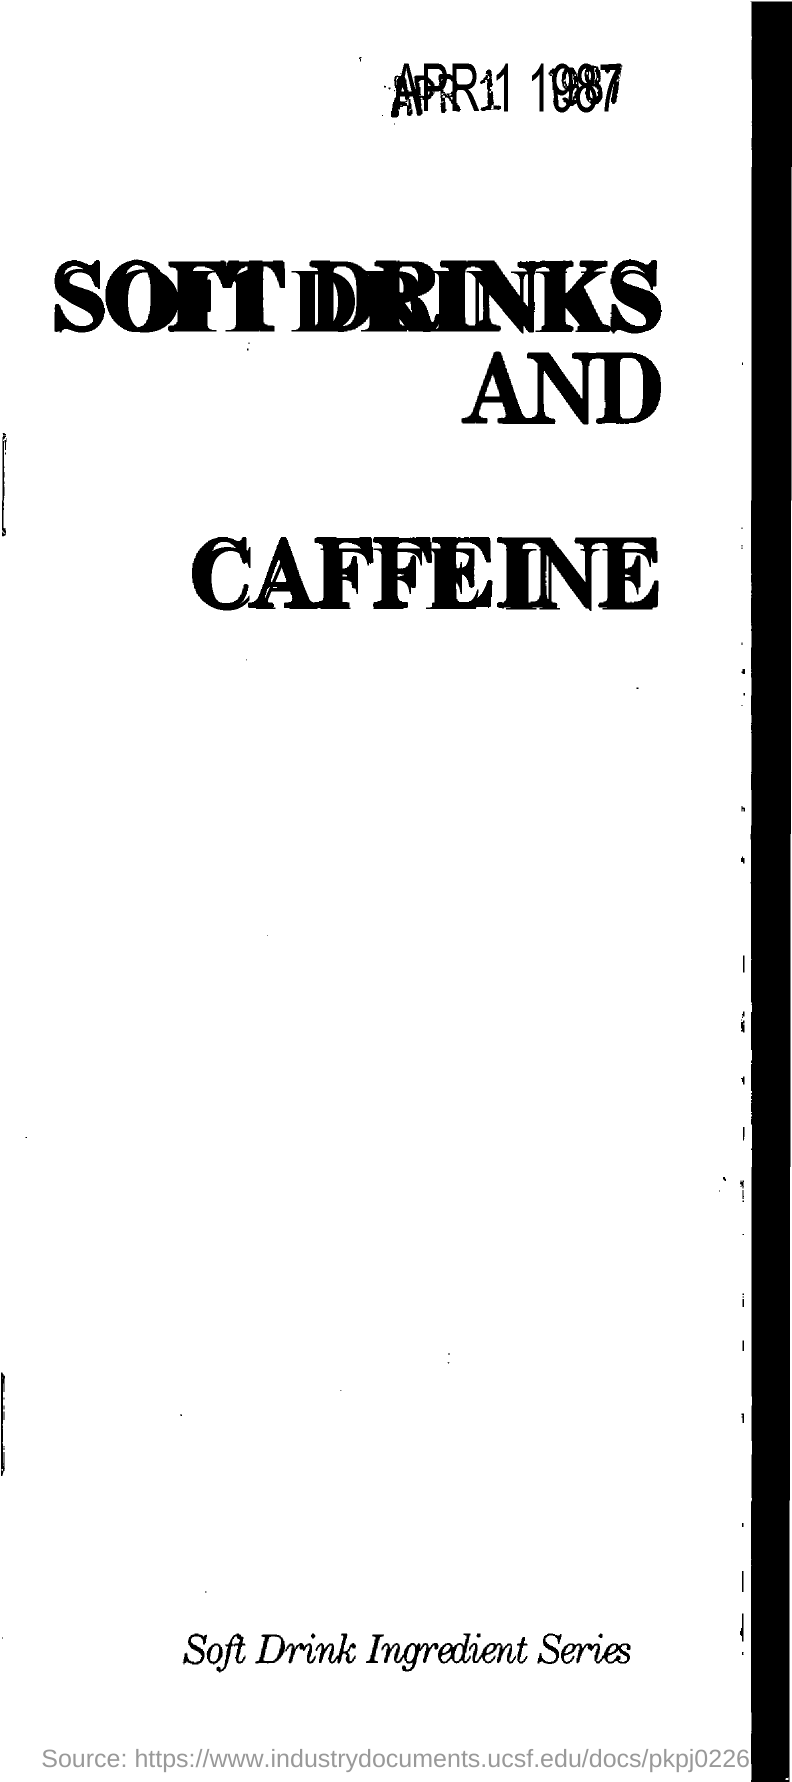What sort of document series does it covers ?
Your response must be concise. Soft Drink Ingredient Series. What is the title of the series?
Offer a terse response. SOFT DRINKS AND CAFFEINE. What is the title of the document?
Your response must be concise. SOFT DRINKS AND CAFFEINE. 